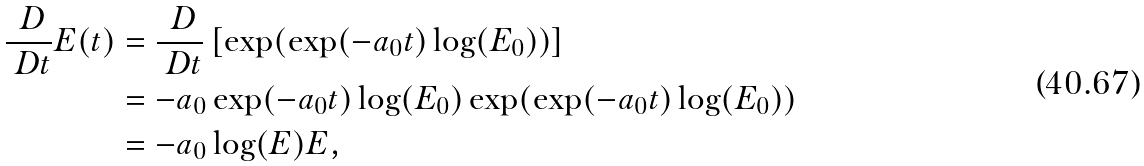Convert formula to latex. <formula><loc_0><loc_0><loc_500><loc_500>\frac { \ D } { \ D t } E ( t ) & = \frac { \ D } { \ D t } \left [ \exp ( \exp ( - a _ { 0 } t ) \log ( E _ { 0 } ) ) \right ] \\ & = - a _ { 0 } \exp ( - a _ { 0 } t ) \log ( E _ { 0 } ) \exp ( \exp ( - a _ { 0 } t ) \log ( E _ { 0 } ) ) \\ & = - a _ { 0 } \log ( E ) E ,</formula> 